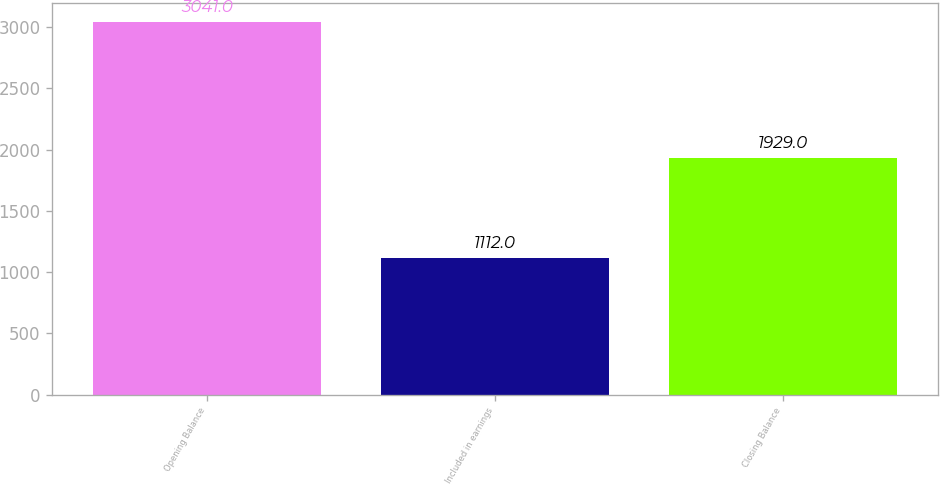Convert chart to OTSL. <chart><loc_0><loc_0><loc_500><loc_500><bar_chart><fcel>Opening Balance<fcel>Included in earnings<fcel>Closing Balance<nl><fcel>3041<fcel>1112<fcel>1929<nl></chart> 